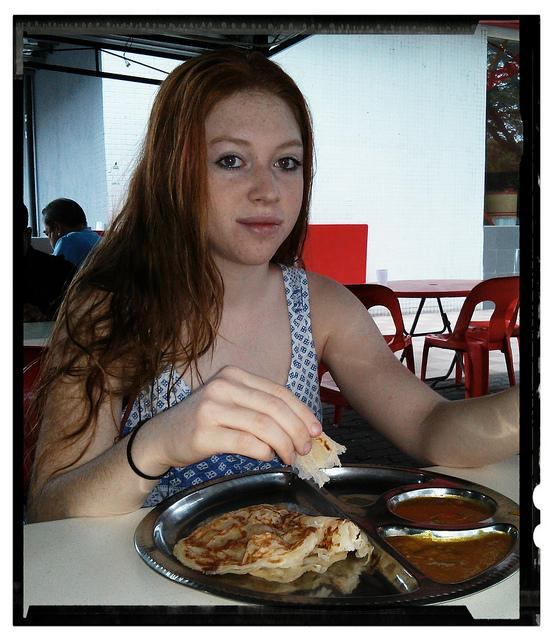What kind of bread is this? naan 